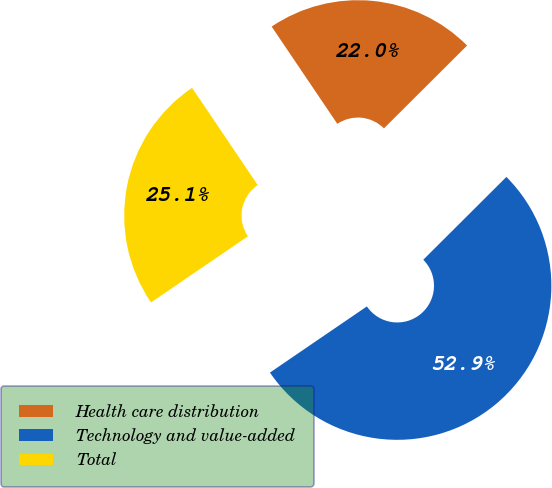<chart> <loc_0><loc_0><loc_500><loc_500><pie_chart><fcel>Health care distribution<fcel>Technology and value-added<fcel>Total<nl><fcel>21.98%<fcel>52.94%<fcel>25.08%<nl></chart> 